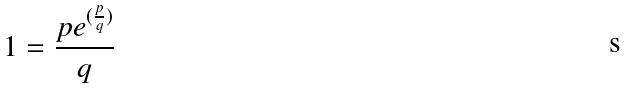<formula> <loc_0><loc_0><loc_500><loc_500>1 = \frac { p e ^ { ( \frac { p } { q } ) } } { q }</formula> 